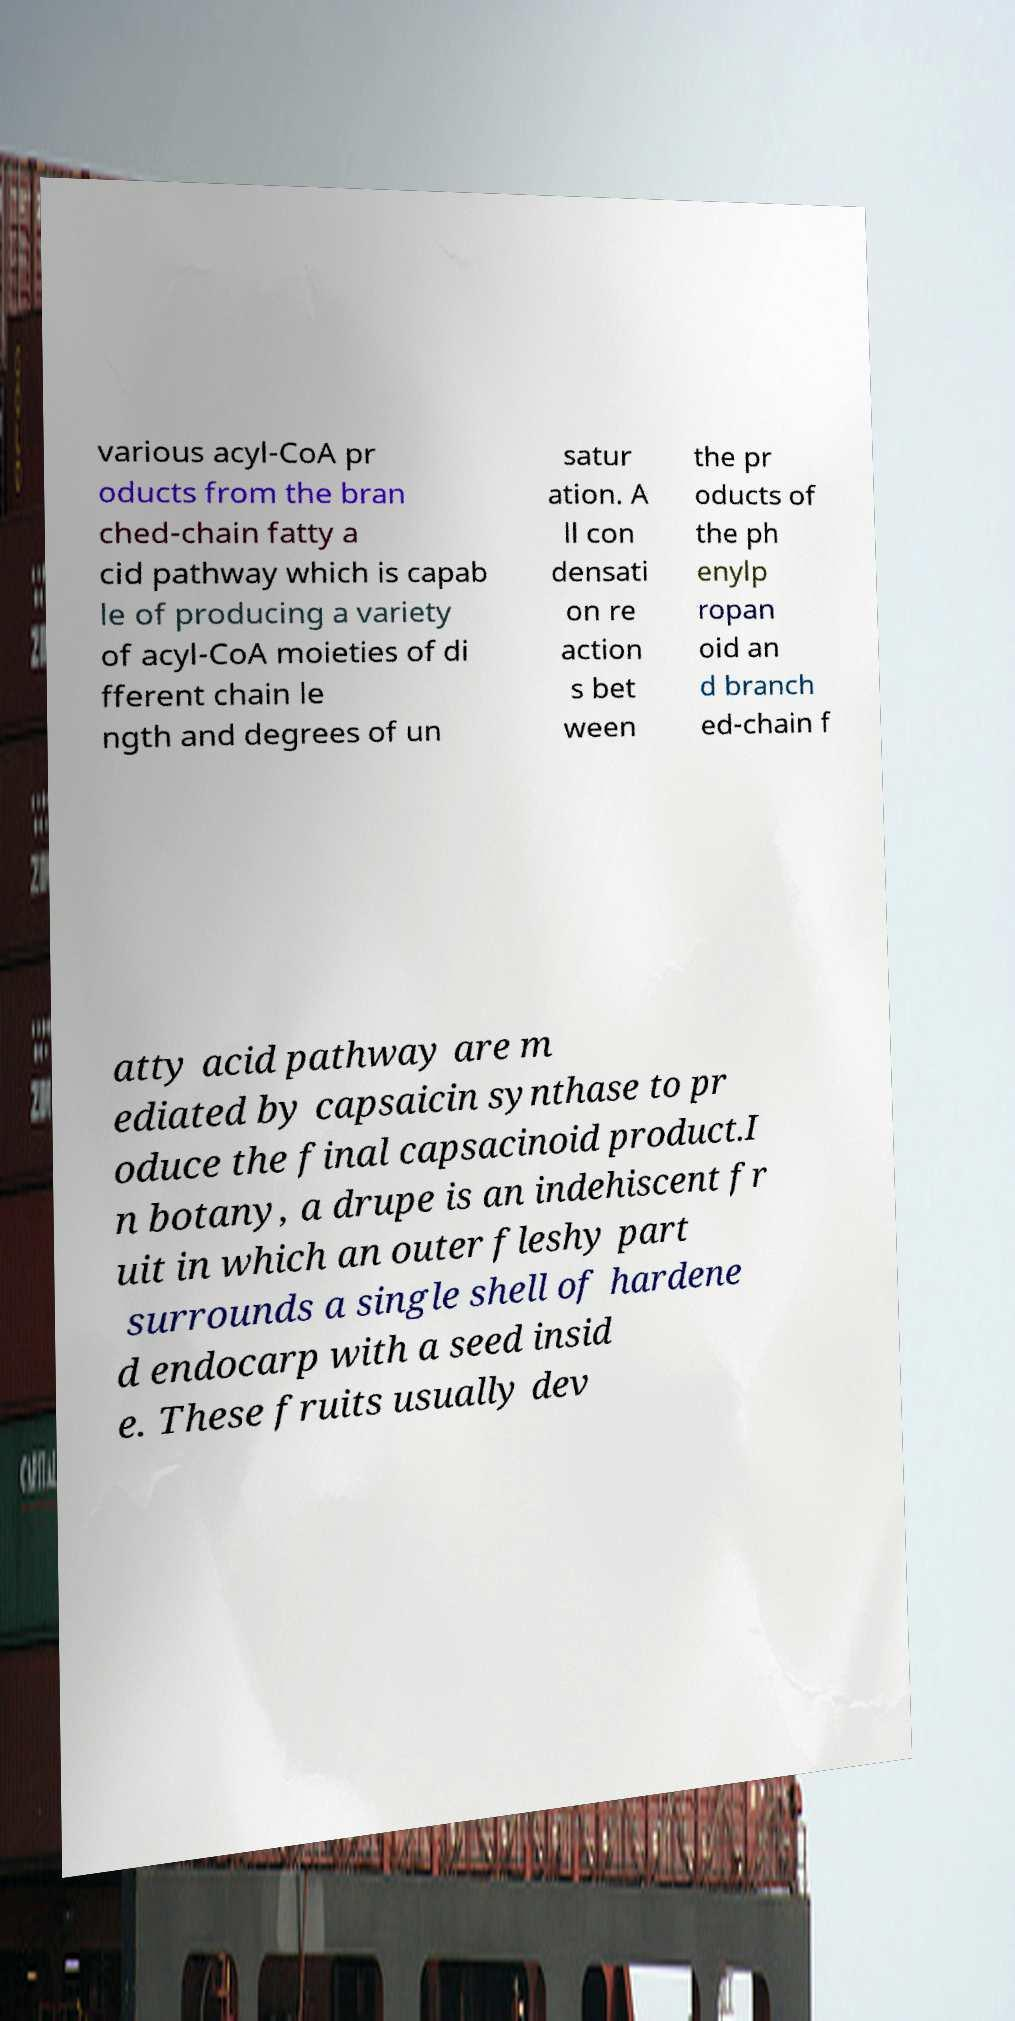What messages or text are displayed in this image? I need them in a readable, typed format. various acyl-CoA pr oducts from the bran ched-chain fatty a cid pathway which is capab le of producing a variety of acyl-CoA moieties of di fferent chain le ngth and degrees of un satur ation. A ll con densati on re action s bet ween the pr oducts of the ph enylp ropan oid an d branch ed-chain f atty acid pathway are m ediated by capsaicin synthase to pr oduce the final capsacinoid product.I n botany, a drupe is an indehiscent fr uit in which an outer fleshy part surrounds a single shell of hardene d endocarp with a seed insid e. These fruits usually dev 